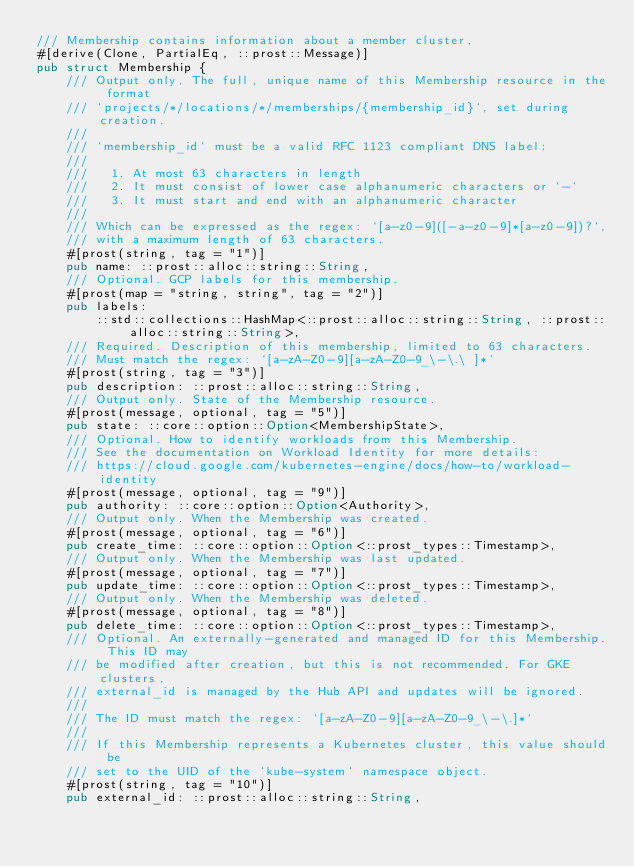Convert code to text. <code><loc_0><loc_0><loc_500><loc_500><_Rust_>/// Membership contains information about a member cluster.
#[derive(Clone, PartialEq, ::prost::Message)]
pub struct Membership {
    /// Output only. The full, unique name of this Membership resource in the format
    /// `projects/*/locations/*/memberships/{membership_id}`, set during creation.
    ///
    /// `membership_id` must be a valid RFC 1123 compliant DNS label:
    ///
    ///   1. At most 63 characters in length
    ///   2. It must consist of lower case alphanumeric characters or `-`
    ///   3. It must start and end with an alphanumeric character
    ///
    /// Which can be expressed as the regex: `[a-z0-9]([-a-z0-9]*[a-z0-9])?`,
    /// with a maximum length of 63 characters.
    #[prost(string, tag = "1")]
    pub name: ::prost::alloc::string::String,
    /// Optional. GCP labels for this membership.
    #[prost(map = "string, string", tag = "2")]
    pub labels:
        ::std::collections::HashMap<::prost::alloc::string::String, ::prost::alloc::string::String>,
    /// Required. Description of this membership, limited to 63 characters.
    /// Must match the regex: `[a-zA-Z0-9][a-zA-Z0-9_\-\.\ ]*`
    #[prost(string, tag = "3")]
    pub description: ::prost::alloc::string::String,
    /// Output only. State of the Membership resource.
    #[prost(message, optional, tag = "5")]
    pub state: ::core::option::Option<MembershipState>,
    /// Optional. How to identify workloads from this Membership.
    /// See the documentation on Workload Identity for more details:
    /// https://cloud.google.com/kubernetes-engine/docs/how-to/workload-identity
    #[prost(message, optional, tag = "9")]
    pub authority: ::core::option::Option<Authority>,
    /// Output only. When the Membership was created.
    #[prost(message, optional, tag = "6")]
    pub create_time: ::core::option::Option<::prost_types::Timestamp>,
    /// Output only. When the Membership was last updated.
    #[prost(message, optional, tag = "7")]
    pub update_time: ::core::option::Option<::prost_types::Timestamp>,
    /// Output only. When the Membership was deleted.
    #[prost(message, optional, tag = "8")]
    pub delete_time: ::core::option::Option<::prost_types::Timestamp>,
    /// Optional. An externally-generated and managed ID for this Membership. This ID may
    /// be modified after creation, but this is not recommended. For GKE clusters,
    /// external_id is managed by the Hub API and updates will be ignored.
    ///
    /// The ID must match the regex: `[a-zA-Z0-9][a-zA-Z0-9_\-\.]*`
    ///
    /// If this Membership represents a Kubernetes cluster, this value should be
    /// set to the UID of the `kube-system` namespace object.
    #[prost(string, tag = "10")]
    pub external_id: ::prost::alloc::string::String,</code> 